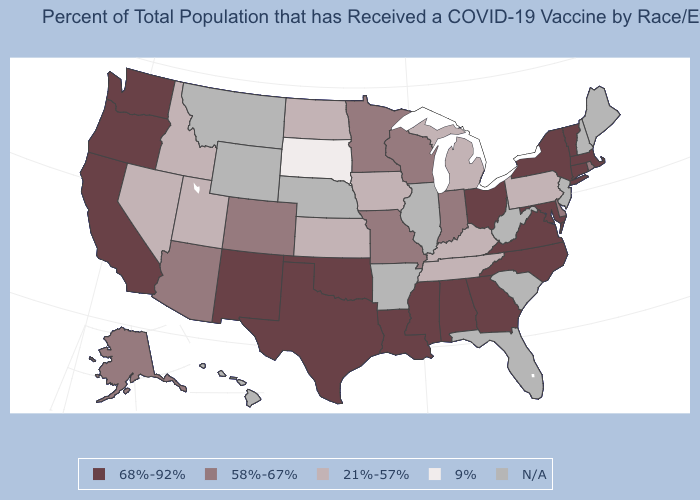Name the states that have a value in the range N/A?
Keep it brief. Arkansas, Florida, Hawaii, Illinois, Maine, Montana, Nebraska, New Hampshire, New Jersey, South Carolina, West Virginia, Wyoming. What is the value of Michigan?
Concise answer only. 21%-57%. Which states have the lowest value in the USA?
Answer briefly. South Dakota. Name the states that have a value in the range 9%?
Quick response, please. South Dakota. What is the lowest value in the USA?
Be succinct. 9%. Does New Mexico have the highest value in the USA?
Be succinct. Yes. What is the highest value in the Northeast ?
Give a very brief answer. 68%-92%. Name the states that have a value in the range 68%-92%?
Quick response, please. Alabama, California, Connecticut, Georgia, Louisiana, Maryland, Massachusetts, Mississippi, New Mexico, New York, North Carolina, Ohio, Oklahoma, Oregon, Texas, Vermont, Virginia, Washington. Name the states that have a value in the range 58%-67%?
Concise answer only. Alaska, Arizona, Colorado, Delaware, Indiana, Minnesota, Missouri, Rhode Island, Wisconsin. What is the highest value in the South ?
Keep it brief. 68%-92%. Which states have the lowest value in the USA?
Short answer required. South Dakota. What is the value of Oregon?
Short answer required. 68%-92%. Does Colorado have the lowest value in the USA?
Answer briefly. No. What is the value of Virginia?
Answer briefly. 68%-92%. 